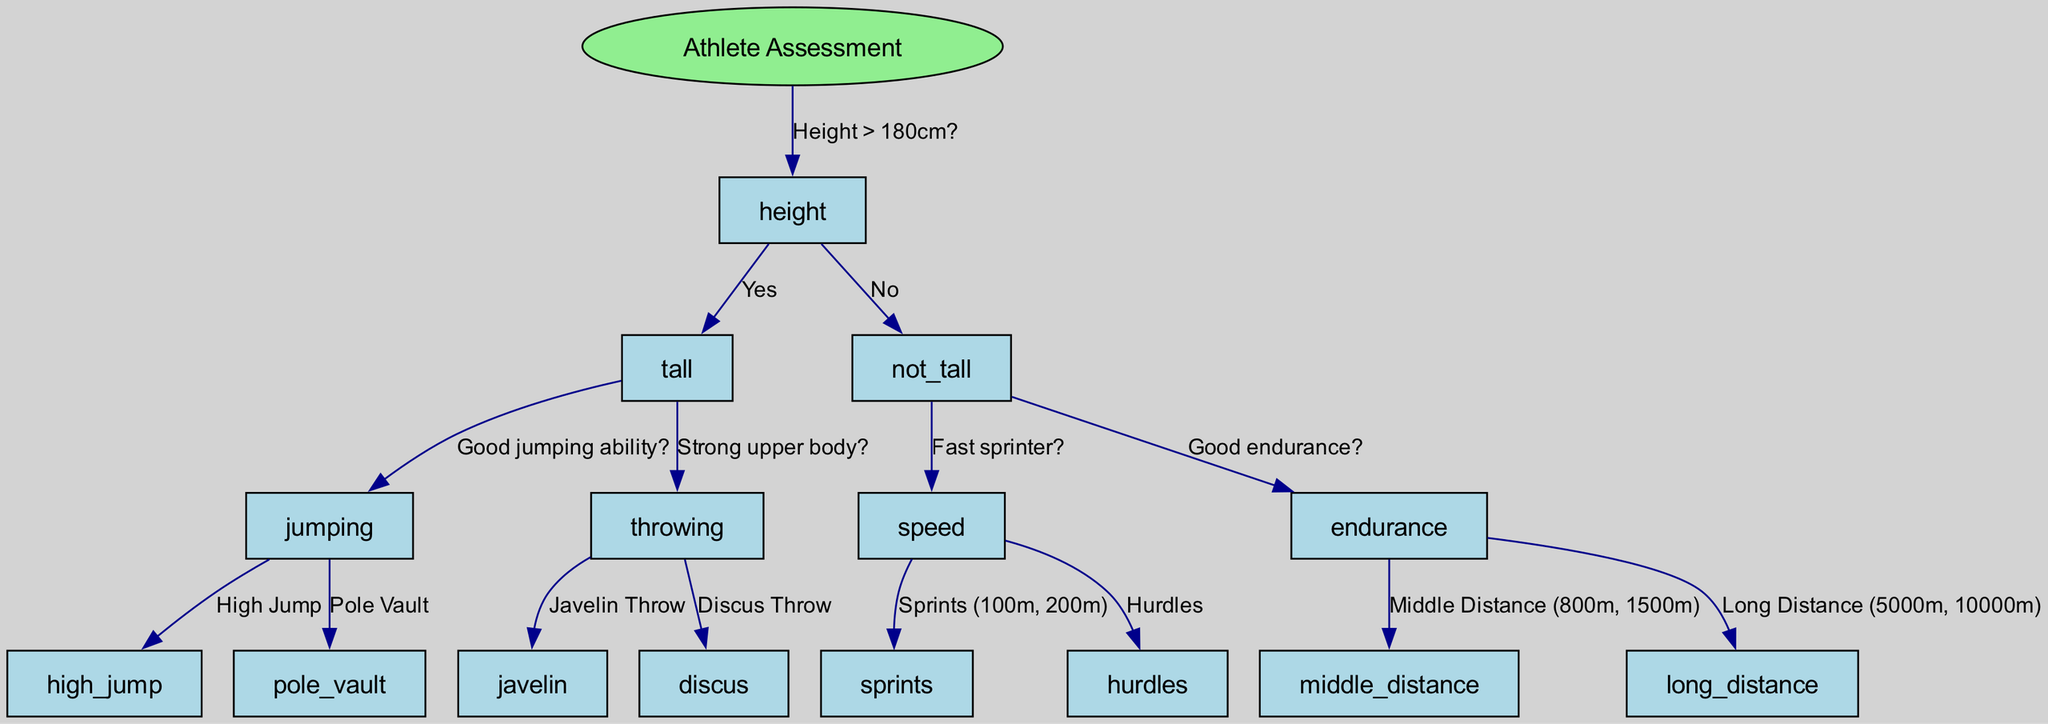What is the root node of the diagram? The root node is labeled "Athlete Assessment".
Answer: Athlete Assessment How many main branches does the diagram have? There are two main branches from the root node based on height: "Yes" for height greater than 180cm and "No" for height not greater than 180cm.
Answer: Two What are the two events listed under "Good jumping ability?" The events listed are "High Jump" and "Pole Vault".
Answer: High Jump, Pole Vault What is the outcome if the athlete's height is not greater than 180 cm and they are a fast sprinter? If the athlete is a fast sprinter, the outcome leads to "Sprints (100m, 200m)".
Answer: Sprints (100m, 200m) Which event is recommended for an athlete who is tall and has strong upper body strength? The recommended event is "Javelin Throw".
Answer: Javelin Throw If an athlete is not tall and has good endurance, which events can they choose from? The options for this athlete are "Middle Distance (800m, 1500m)" and "Long Distance (5000m, 10000m)".
Answer: Middle Distance (800m, 1500m), Long Distance (5000m, 10000m) In the diagram, what happens after confirming that an athlete’s height is greater than 180 cm and they possess good jumping ability? If both conditions are met, the athlete can participate in either "High Jump" or "Pole Vault".
Answer: High Jump, Pole Vault How does the decision tree differentiate between tall and not tall athletes? The decision tree uses height as the primary criterion, with a question about whether height is greater than 180 cm.
Answer: Height > 180cm? 